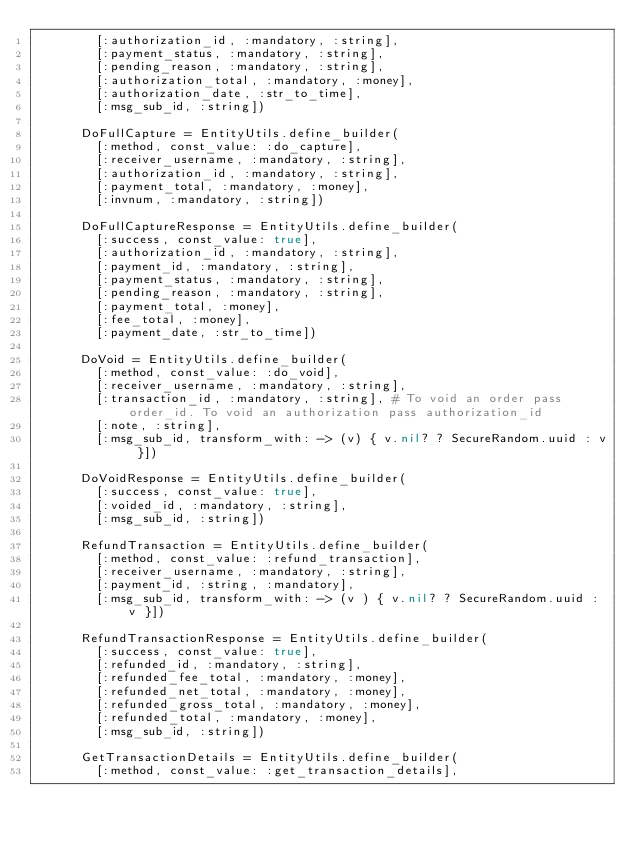Convert code to text. <code><loc_0><loc_0><loc_500><loc_500><_Ruby_>        [:authorization_id, :mandatory, :string],
        [:payment_status, :mandatory, :string],
        [:pending_reason, :mandatory, :string],
        [:authorization_total, :mandatory, :money],
        [:authorization_date, :str_to_time],
        [:msg_sub_id, :string])

      DoFullCapture = EntityUtils.define_builder(
        [:method, const_value: :do_capture],
        [:receiver_username, :mandatory, :string],
        [:authorization_id, :mandatory, :string],
        [:payment_total, :mandatory, :money],
        [:invnum, :mandatory, :string])

      DoFullCaptureResponse = EntityUtils.define_builder(
        [:success, const_value: true],
        [:authorization_id, :mandatory, :string],
        [:payment_id, :mandatory, :string],
        [:payment_status, :mandatory, :string],
        [:pending_reason, :mandatory, :string],
        [:payment_total, :money],
        [:fee_total, :money],
        [:payment_date, :str_to_time])

      DoVoid = EntityUtils.define_builder(
        [:method, const_value: :do_void],
        [:receiver_username, :mandatory, :string],
        [:transaction_id, :mandatory, :string], # To void an order pass order_id. To void an authorization pass authorization_id
        [:note, :string],
        [:msg_sub_id, transform_with: -> (v) { v.nil? ? SecureRandom.uuid : v }])

      DoVoidResponse = EntityUtils.define_builder(
        [:success, const_value: true],
        [:voided_id, :mandatory, :string],
        [:msg_sub_id, :string])

      RefundTransaction = EntityUtils.define_builder(
        [:method, const_value: :refund_transaction],
        [:receiver_username, :mandatory, :string],
        [:payment_id, :string, :mandatory],
        [:msg_sub_id, transform_with: -> (v ) { v.nil? ? SecureRandom.uuid : v }])

      RefundTransactionResponse = EntityUtils.define_builder(
        [:success, const_value: true],
        [:refunded_id, :mandatory, :string],
        [:refunded_fee_total, :mandatory, :money],
        [:refunded_net_total, :mandatory, :money],
        [:refunded_gross_total, :mandatory, :money],
        [:refunded_total, :mandatory, :money],
        [:msg_sub_id, :string])

      GetTransactionDetails = EntityUtils.define_builder(
        [:method, const_value: :get_transaction_details],</code> 